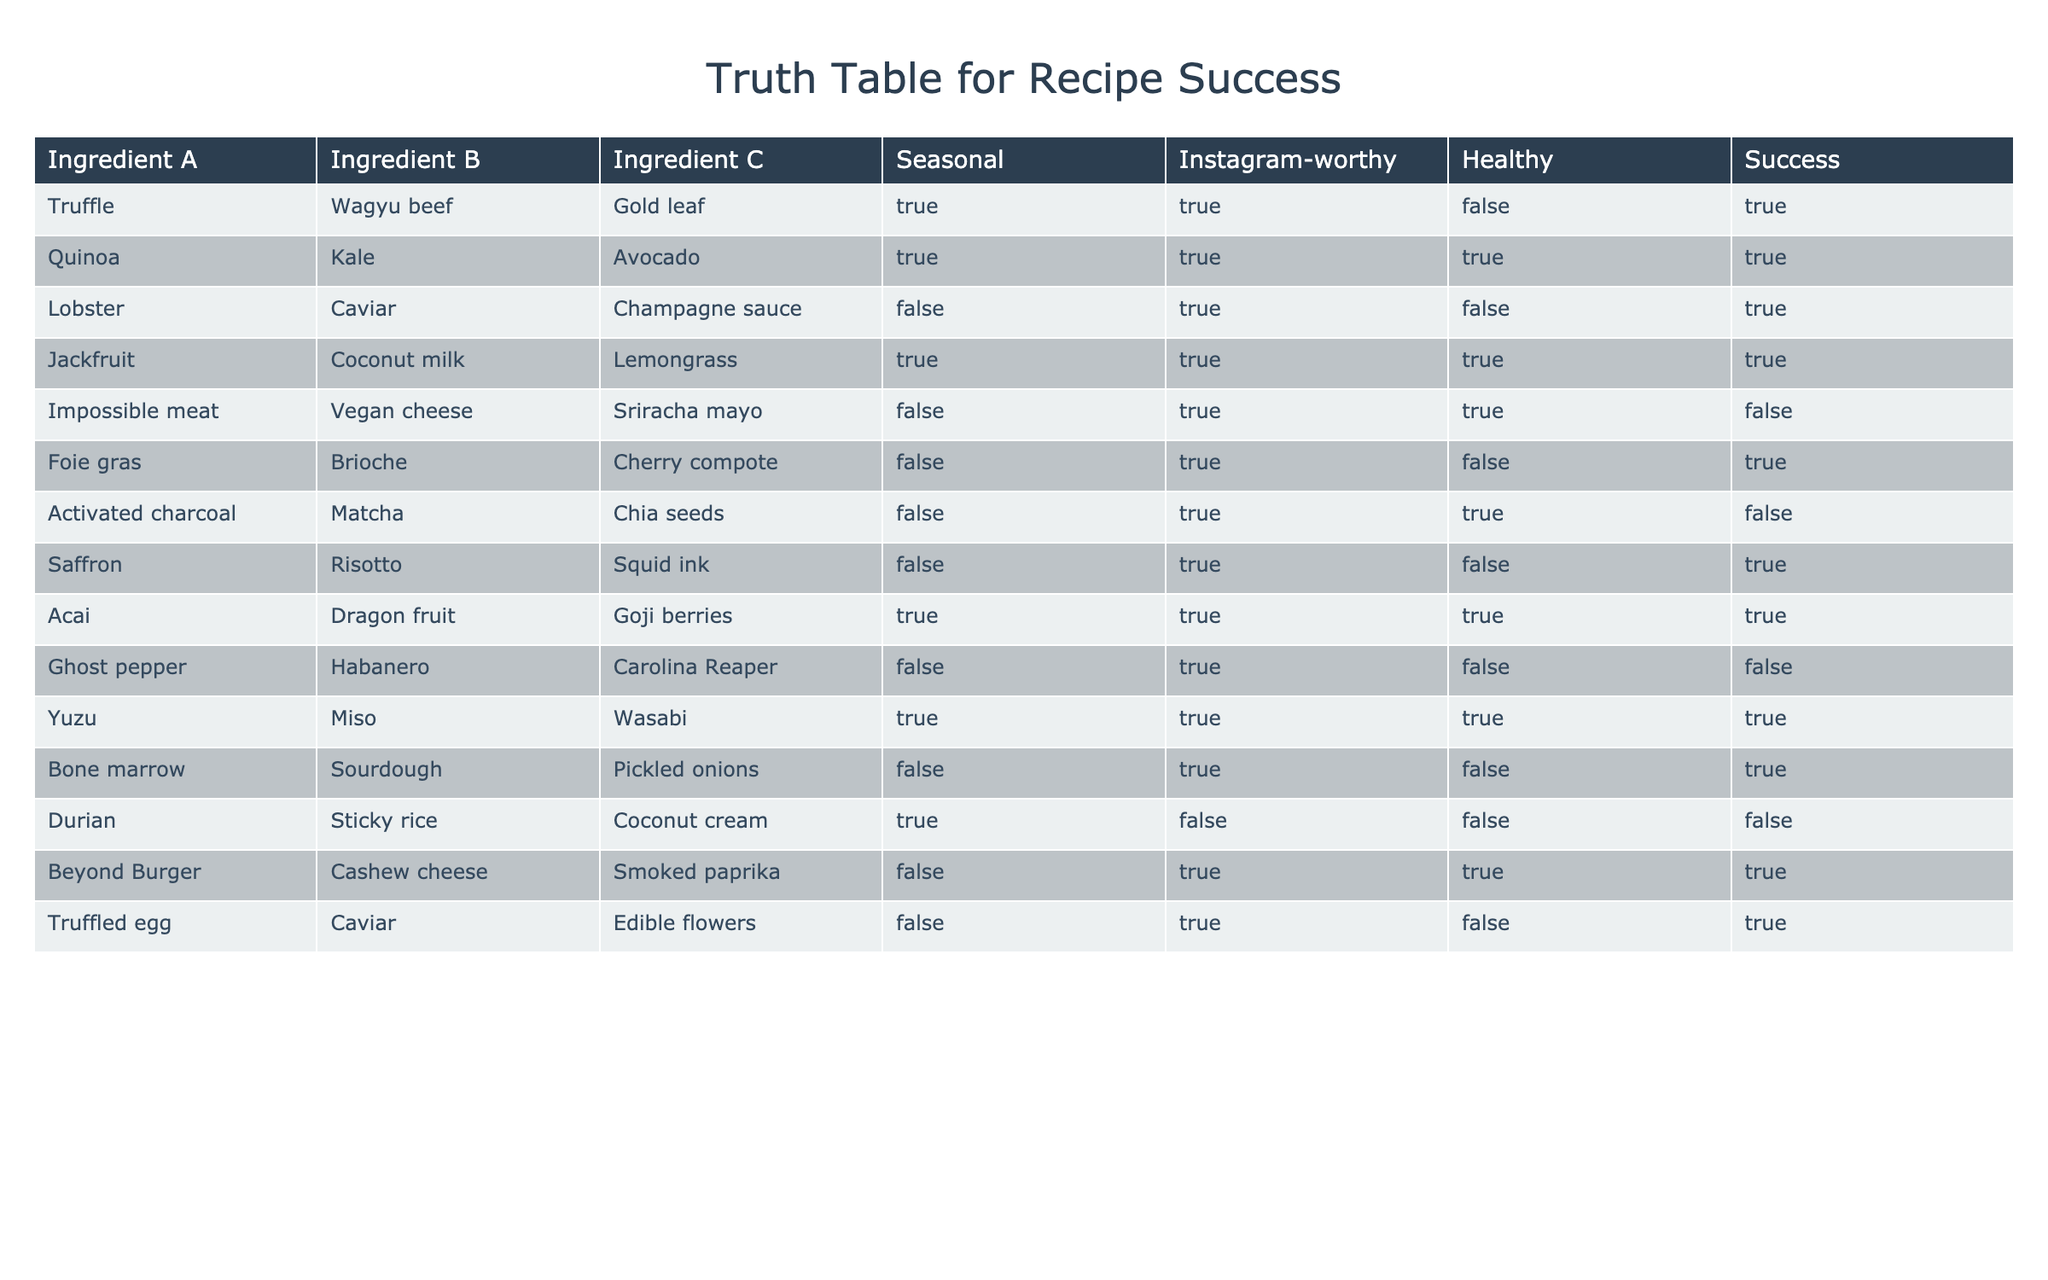What are the ingredients for the recipe that had the highest success rate? The recipe with the highest success rate is the one with the ingredients Truffle, Wagyu beef, and Gold leaf, which is marked as having a success of TRUE.
Answer: Truffle, Wagyu beef, Gold leaf How many recipes in the table are marked as Instagram-worthy? By counting the entries in the Instagram-worthy column marked TRUE, we find 8 recipes fit this criterion.
Answer: 8 Is there a successful recipe that includes avocado? The recipe with Avocado is the one with Quinoa and Kale, which is marked as a success.
Answer: Yes What is the total number of unique ingredients used across all recipes? By compiling a list of all unique ingredients in the Ingredient A, B, and C columns, we find there are 12 different ingredients used across the recipes.
Answer: 12 How many recipes are labeled as healthy and successful? Reviewing the Healthy and Success columns, only one recipe, Quinoa, Kale, Avocado, is labeled as both healthy and successful.
Answer: 1 Which ingredient combination had the fewest successful outcomes? The recipe with Ghost pepper, Habanero, Caroline Reaper had no success (marked FALSE), which indicates this combination had the fewest successful outcomes.
Answer: Ghost pepper, Habanero, Carolina Reaper Are there any recipes that are seasonal and healthy but not successful? Yes, the recipe with Impossible meat, Vegan cheese, and Sriracha mayo is seasonal and healthy but labeled as not successful.
Answer: Yes What is the count of recipes that were both seasonal and not healthy? By checking the Seasonal and Healthy columns, we find that two recipes, Durian, Sticky rice, Coconut cream, and Activated charcoal, Matcha, Chia seeds, are both seasonal and not healthy.
Answer: 2 How many total successful recipes are found in the table? By counting the entries in the Success column that are marked TRUE, we find there are six successful recipes in total.
Answer: 6 